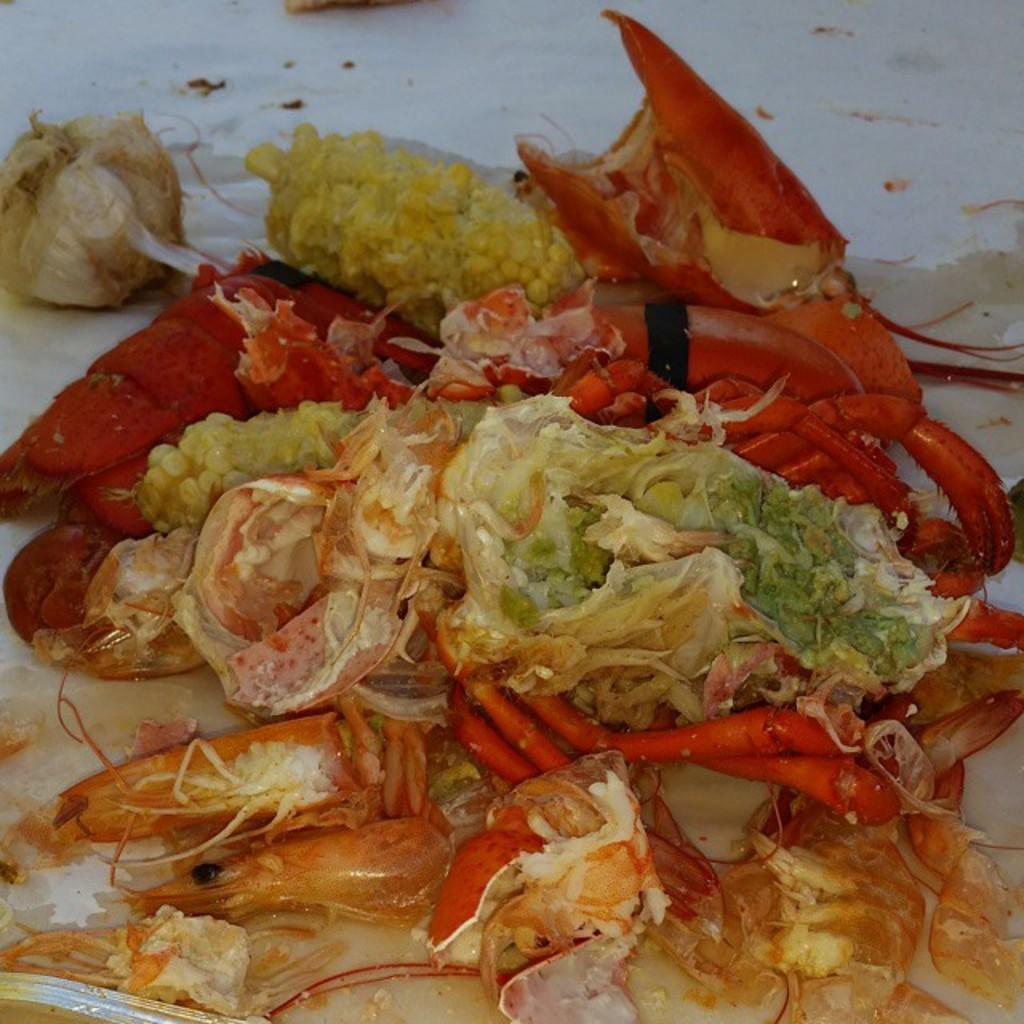What is on the plate that is visible in the image? The plate contains a lobster and corn. What type of seafood is on the plate? The plate contains a lobster. What vegetable is on the plate? The plate contains corn. How many fingers can be seen holding the plate in the image? There are no fingers visible in the image; it only shows a plate with a lobster and corn. 